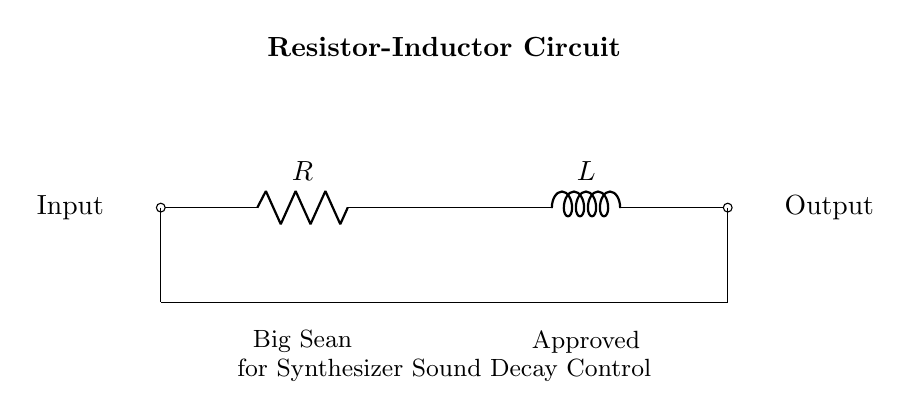What components are present in this circuit? The circuit includes a resistor and an inductor, which are the primary components shown in the diagram.
Answer: Resistor and Inductor What does the output represent in this circuit? The output represents the signal that is affected by the interaction of the resistor and inductor, often used to control sound decay in synthesizers.
Answer: Output signal How are the resistor and inductor connected in this circuit? The resistor and inductor are connected in series, meaning the current flows through the resistor first and then through the inductor.
Answer: Series connection What effect does increasing the resistor value have on sound decay? Increasing the resistor value leads to a slower decay of the sound, as it affects the time constant of the circuit, leading to prolonged sound fading.
Answer: Slower decay What is the intended application of this Resistor-Inductor circuit? The intended application is to control the decay of synthesizer sounds in electronic music production, enhancing the musical output.
Answer: Sound decay control What is the role of the inductor in this circuit? The inductor stores energy in a magnetic field when current passes through it; it helps in shaping the decay characteristics of the sound signal.
Answer: Energy storage How does this circuit enhance electronic music production? This circuit enhances electronic music production by allowing producers to manipulate sound profiles, creating smoother transitions and fades in music.
Answer: Sound manipulation 